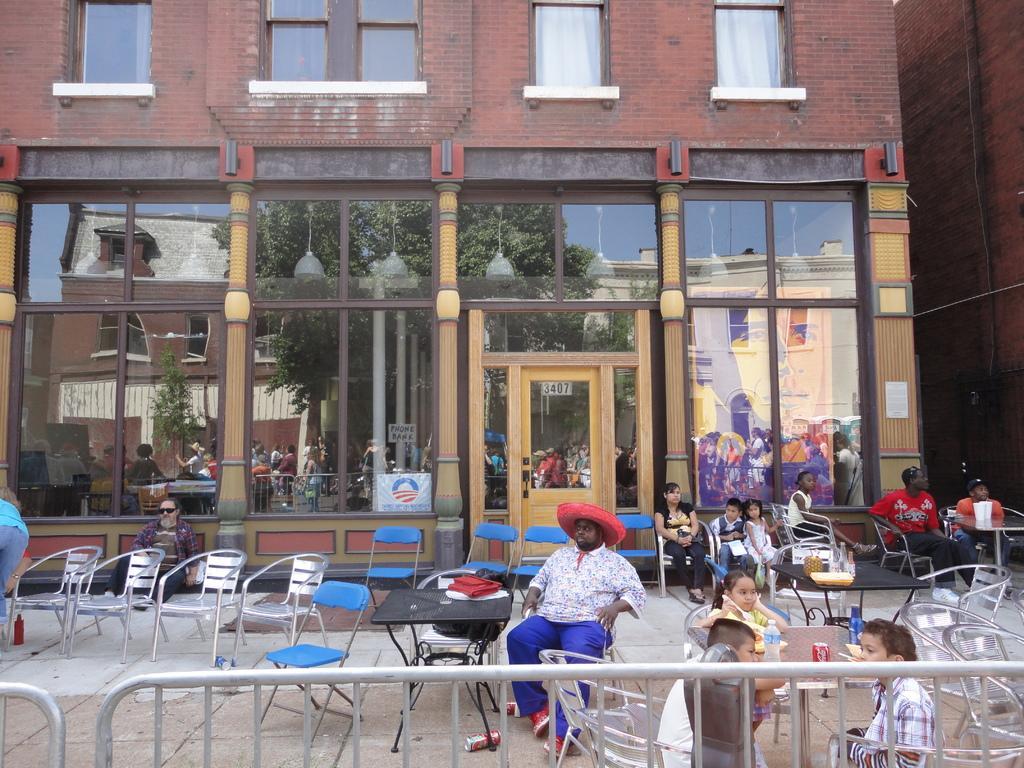How would you summarize this image in a sentence or two? In the image we can see some people were sitting on the chairs,here in the center the man is wearing hat. In front of him there is a table on table there is a backpack and bottom there is a can. And on the left corner there were few chairs,back of chairs one man is sitting down. And back of them there is a building in red color. 